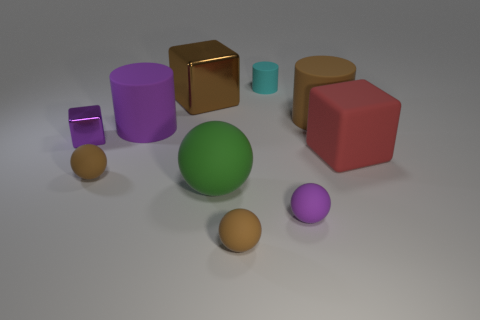Subtract all shiny blocks. How many blocks are left? 1 Subtract all brown blocks. How many brown balls are left? 2 Subtract all balls. How many objects are left? 6 Subtract all brown cylinders. How many cylinders are left? 2 Subtract 1 balls. How many balls are left? 3 Subtract all large brown things. Subtract all small red rubber cylinders. How many objects are left? 8 Add 4 tiny cyan rubber cylinders. How many tiny cyan rubber cylinders are left? 5 Add 8 shiny things. How many shiny things exist? 10 Subtract 0 gray balls. How many objects are left? 10 Subtract all red cylinders. Subtract all brown balls. How many cylinders are left? 3 